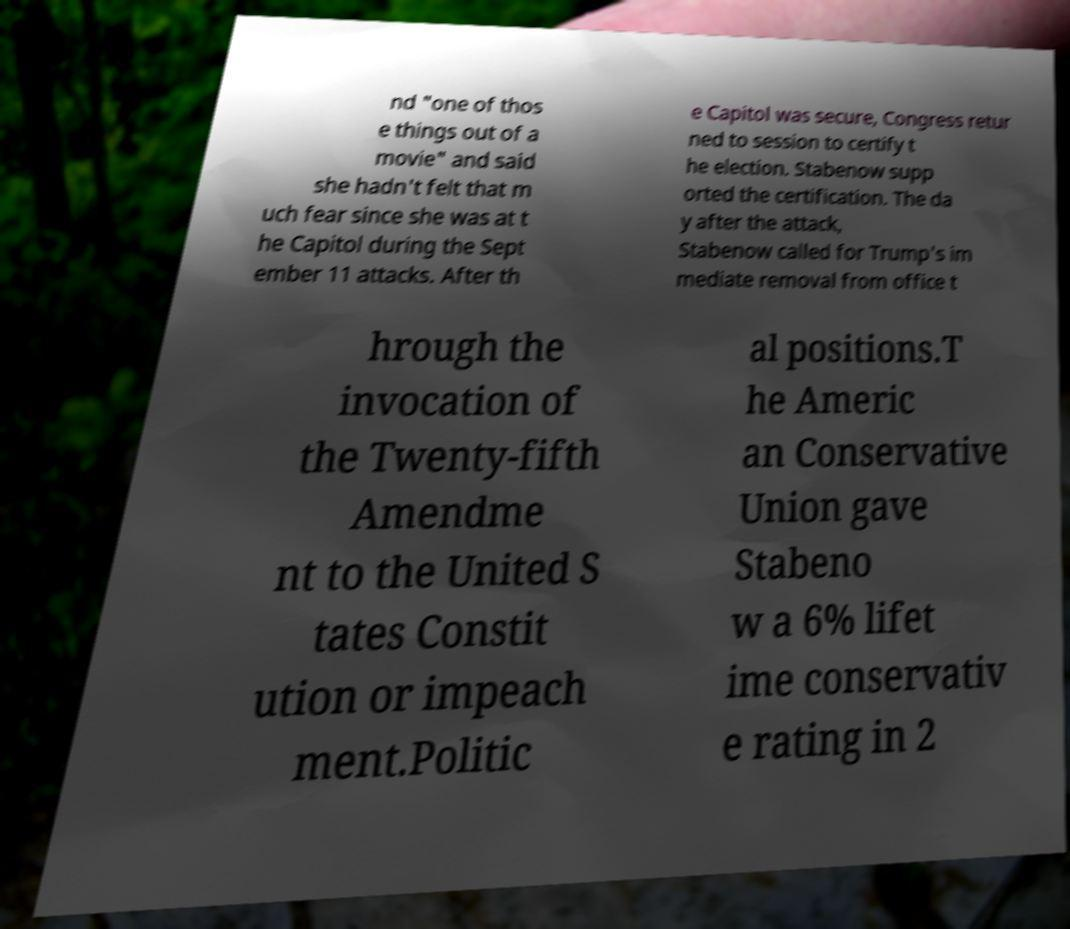Please read and relay the text visible in this image. What does it say? nd "one of thos e things out of a movie" and said she hadn't felt that m uch fear since she was at t he Capitol during the Sept ember 11 attacks. After th e Capitol was secure, Congress retur ned to session to certify t he election. Stabenow supp orted the certification. The da y after the attack, Stabenow called for Trump's im mediate removal from office t hrough the invocation of the Twenty-fifth Amendme nt to the United S tates Constit ution or impeach ment.Politic al positions.T he Americ an Conservative Union gave Stabeno w a 6% lifet ime conservativ e rating in 2 